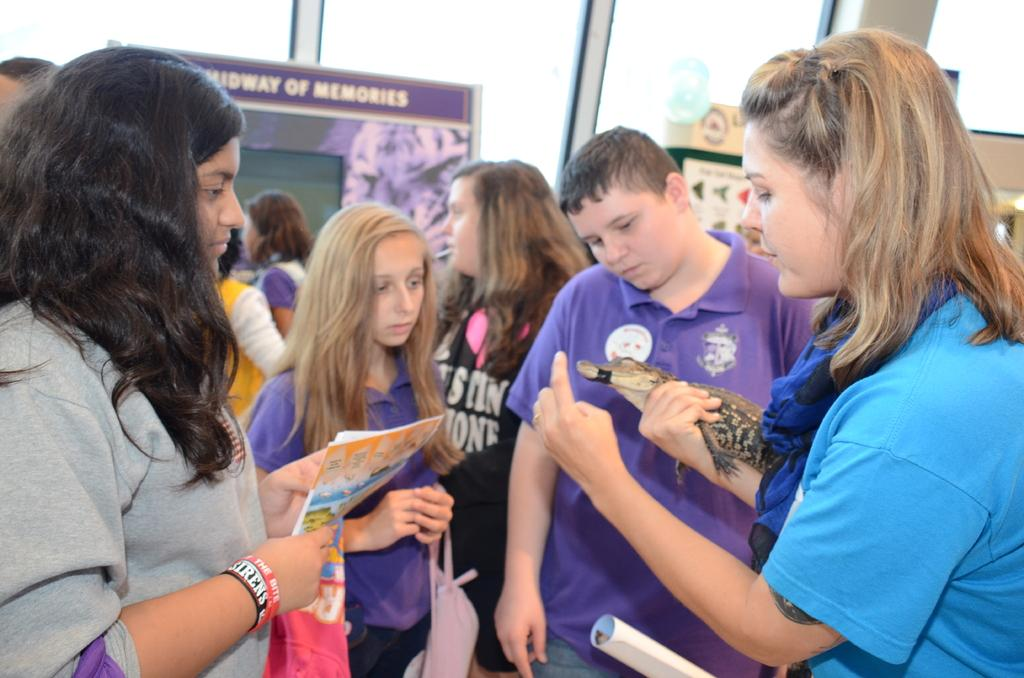What can be observed about the people in the image? There are people in the image. Can you describe the lady's position and action in the image? A lady is standing on the right side of the image, and she is holding a reptile. What is visible in the background of the image? There are boards visible in the background of the image. What type of lawyer is the lady saying good-bye to in the image? There is no lawyer or good-bye gesture present in the image. The lady is holding a reptile and standing on the right side of the image. 